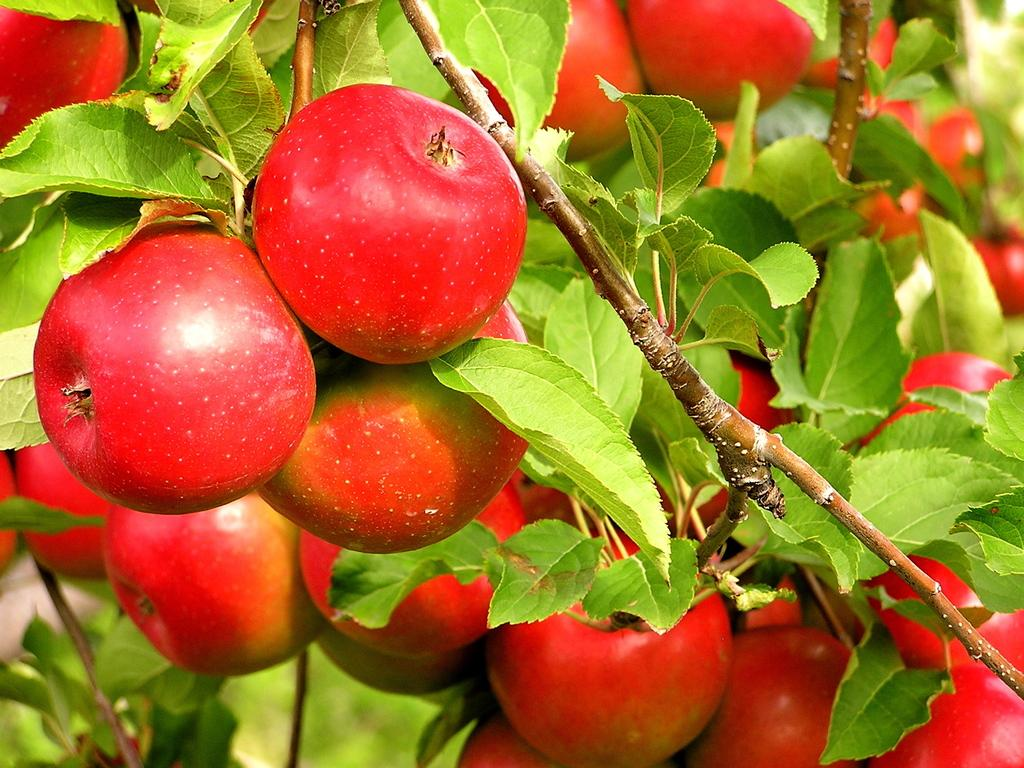What can be seen in the image? There is a tree in the image. What is special about the tree? The tree has fruits on it. What type of bells can be heard ringing in the image? There are no bells present in the image, and therefore no sounds can be heard. 